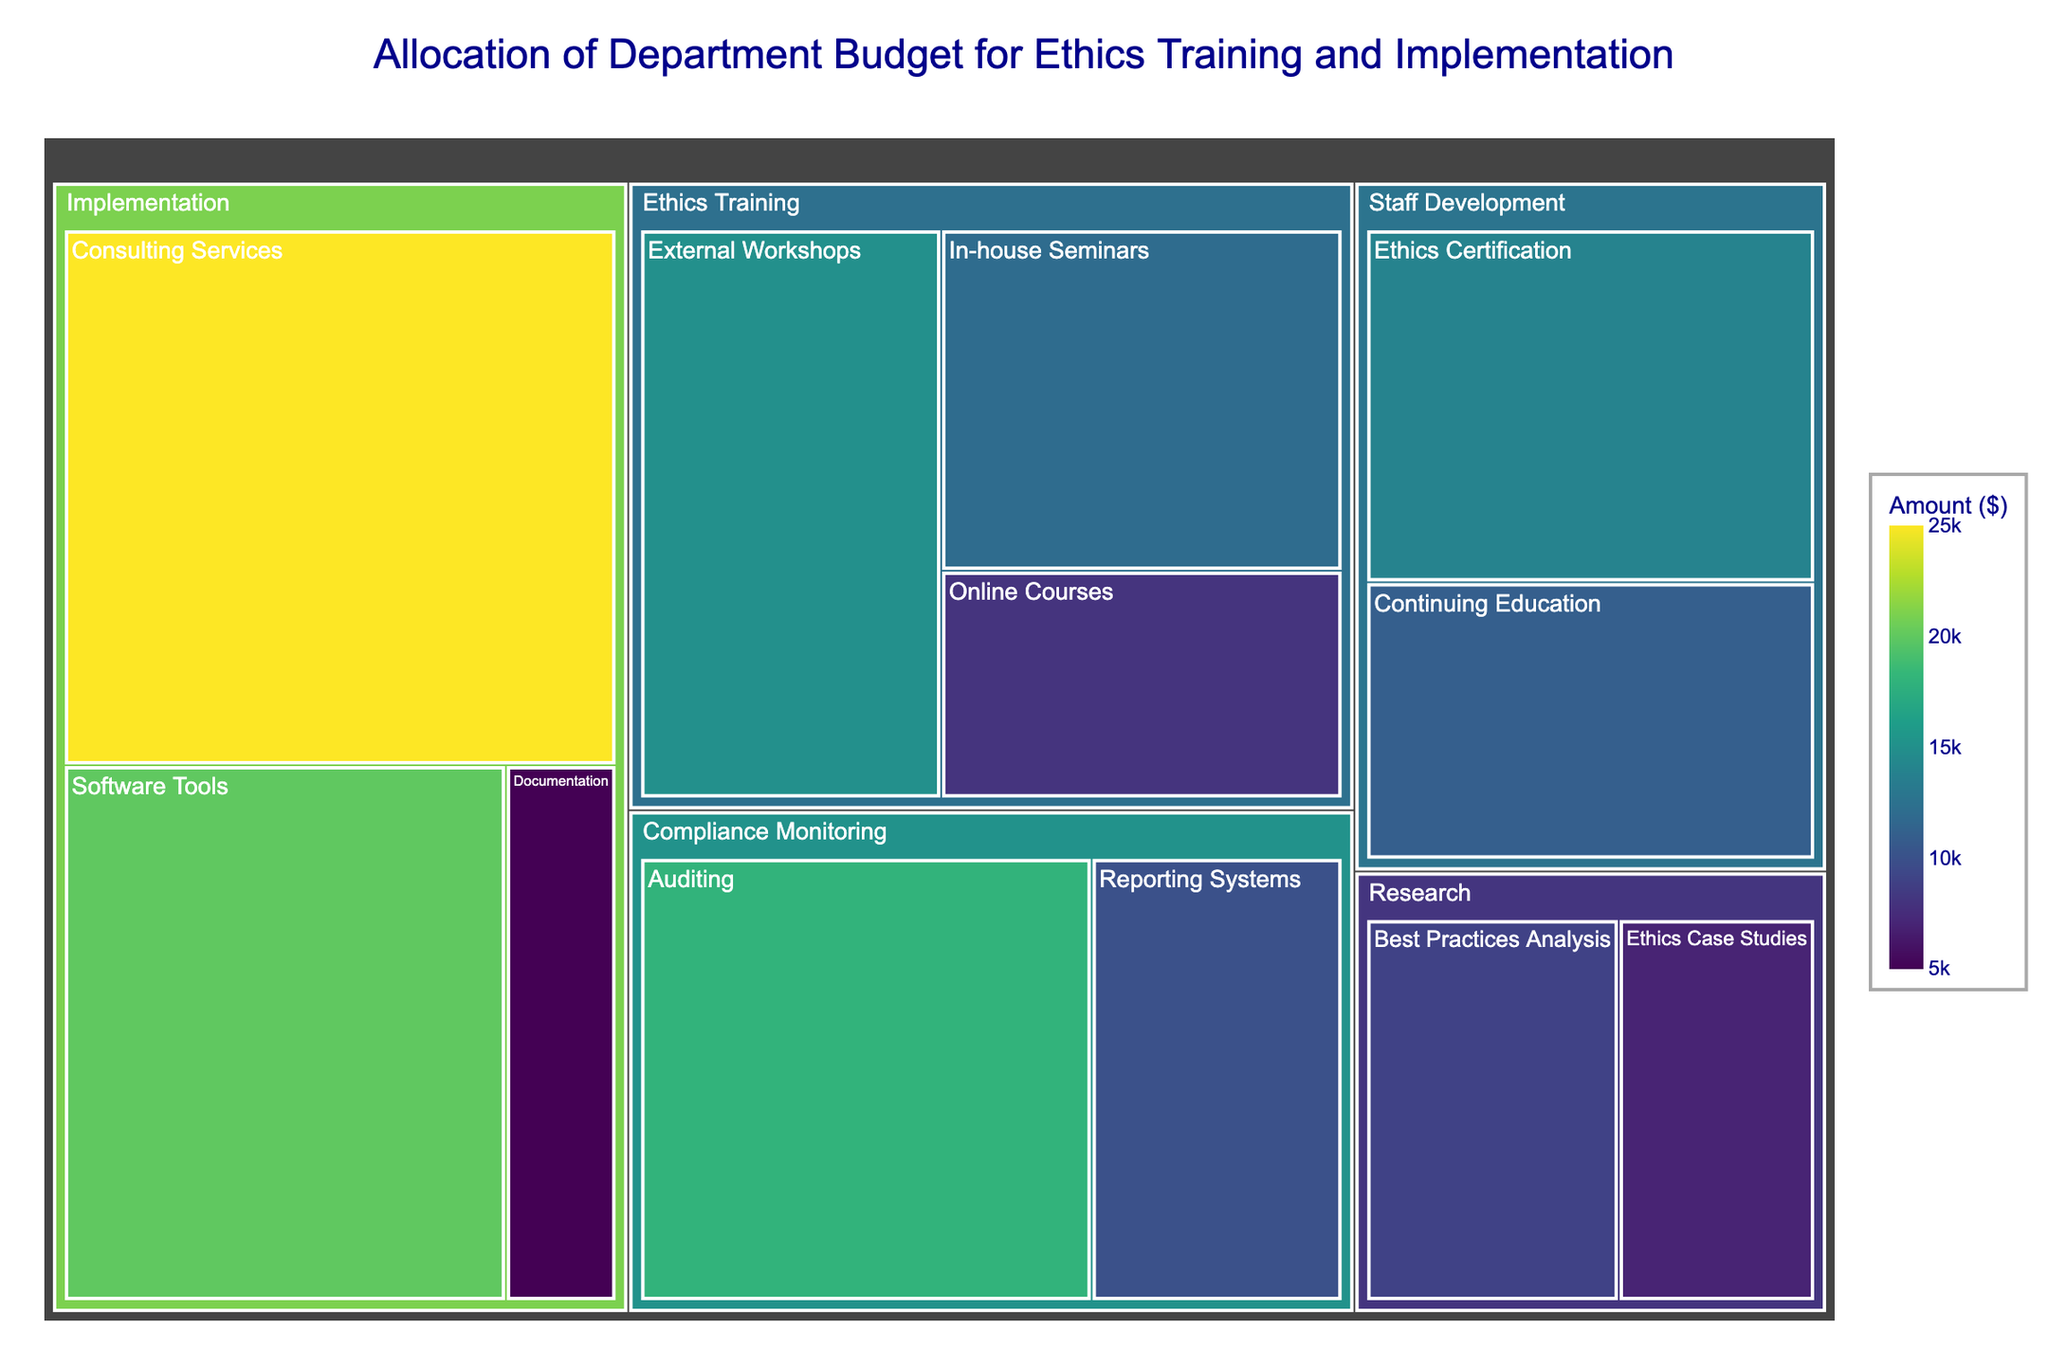what is the total budget allocated for the 'Ethics Training' category? To calculate the total budget for the 'Ethics Training' category, sum the amounts of all its subcategories: External Workshops ($15,000), Online Courses ($8,000), and In-house Seminars ($12,000). So, $15,000 + $8,000 + $12,000 = $35,000
Answer: $35,000 which subcategory within the 'Implementation' category has the highest budget allocation? The 'Implementation' category has three subcategories: Software Tools ($20,000), Consulting Services ($25,000), and Documentation ($5,000). Consulting Services has the highest budget of $25,000
Answer: Consulting Services how does the budget for 'Ethics Case Studies' compare to 'Best Practices Analysis' in the 'Research' category? The budget for 'Ethics Case Studies' is $7,000 and for 'Best Practices Analysis' is $9,000. Comparing these two, 'Best Practices Analysis' has a higher budget by $2,000
Answer: Best Practices Analysis has a higher budget by $2,000 what is the combined budget for 'Staff Development' category? To find the combined budget for 'Staff Development', sum the amounts of its subcategories: Ethics Certification ($14,000) and Continuing Education ($11,000). So, $14,000 + $11,000 = $25,000
Answer: $25,000 what is the smallest subcategory budget in the entire department budget? The smallest subcategory budget can be found by comparing all listed amounts. Documentation under Implementation has the smallest budget of $5,000
Answer: Documentation with $5,000 how much more is allocated to 'Consulting Services' than 'Ethics Certification'? The budget for Consulting Services is $25,000, and for Ethics Certification, it is $14,000. The difference is $25,000 - $14,000 = $11,000
Answer: $11,000 what percentage of the total budget is allocated to 'Compliance Monitoring'? First, calculate the total budget by summing all subcategory amounts: $15,000 (External Workshops) + $8,000 (Online Courses) + $12,000 (In-house Seminars) + $20,000 (Software Tools) + $25,000 (Consulting Services) + $5,000 (Documentation) + $18,000 (Auditing) + $10,000 (Reporting Systems) + $7,000 (Ethics Case Studies) + $9,000 (Best Practices Analysis) + $14,000 (Ethics Certification) + $11,000 (Continuing Education) = $154,000. Then sum the amounts for Compliance Monitoring: $18,000 (Auditing) + $10,000 (Reporting Systems) = $28,000. The percentage is ($28,000 / $154,000) * 100 ≈ 18.18%
Answer: 18.18% what color is used for the highest amount allocated in the Treemap? It is mentioned that the Treemap uses a color gradient (Viridis) to represent different amounts. From the color-continuous scale, the highest amounts typically correspond to the most intense color, which is dark green in the Viridis scale
Answer: Dark green which category has the most subcategories? By counting subcategories in each category: Ethics Training (3), Implementation (3), Compliance Monitoring (2), Research (2), and Staff Development (2). The first two categories, Ethics Training and Implementation, both have the highest number of subcategories, which is 3
Answer: Ethics Training and Implementation how does the budget for 'Auditing' in Compliance Monitoring compare to 'Software Tools' in Implementation? The budget for Auditing is $18,000 and for Software Tools, it is $20,000. Comparing these two, Software Tools has a higher budget by $2,000
Answer: Software Tools has a higher budget by $2,000 